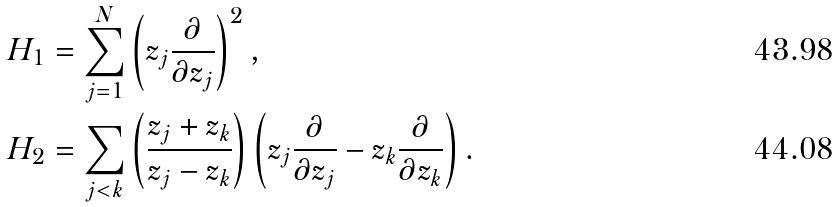Convert formula to latex. <formula><loc_0><loc_0><loc_500><loc_500>& H _ { 1 } = \sum _ { j = 1 } ^ { N } \left ( z _ { j } \frac { \partial } { \partial z _ { j } } \right ) ^ { 2 } , \\ & H _ { 2 } = \sum _ { j < k } \left ( \frac { z _ { j } + z _ { k } } { z _ { j } - z _ { k } } \right ) \left ( z _ { j } \frac { \partial } { \partial z _ { j } } - z _ { k } \frac { \partial } { \partial z _ { k } } \right ) .</formula> 